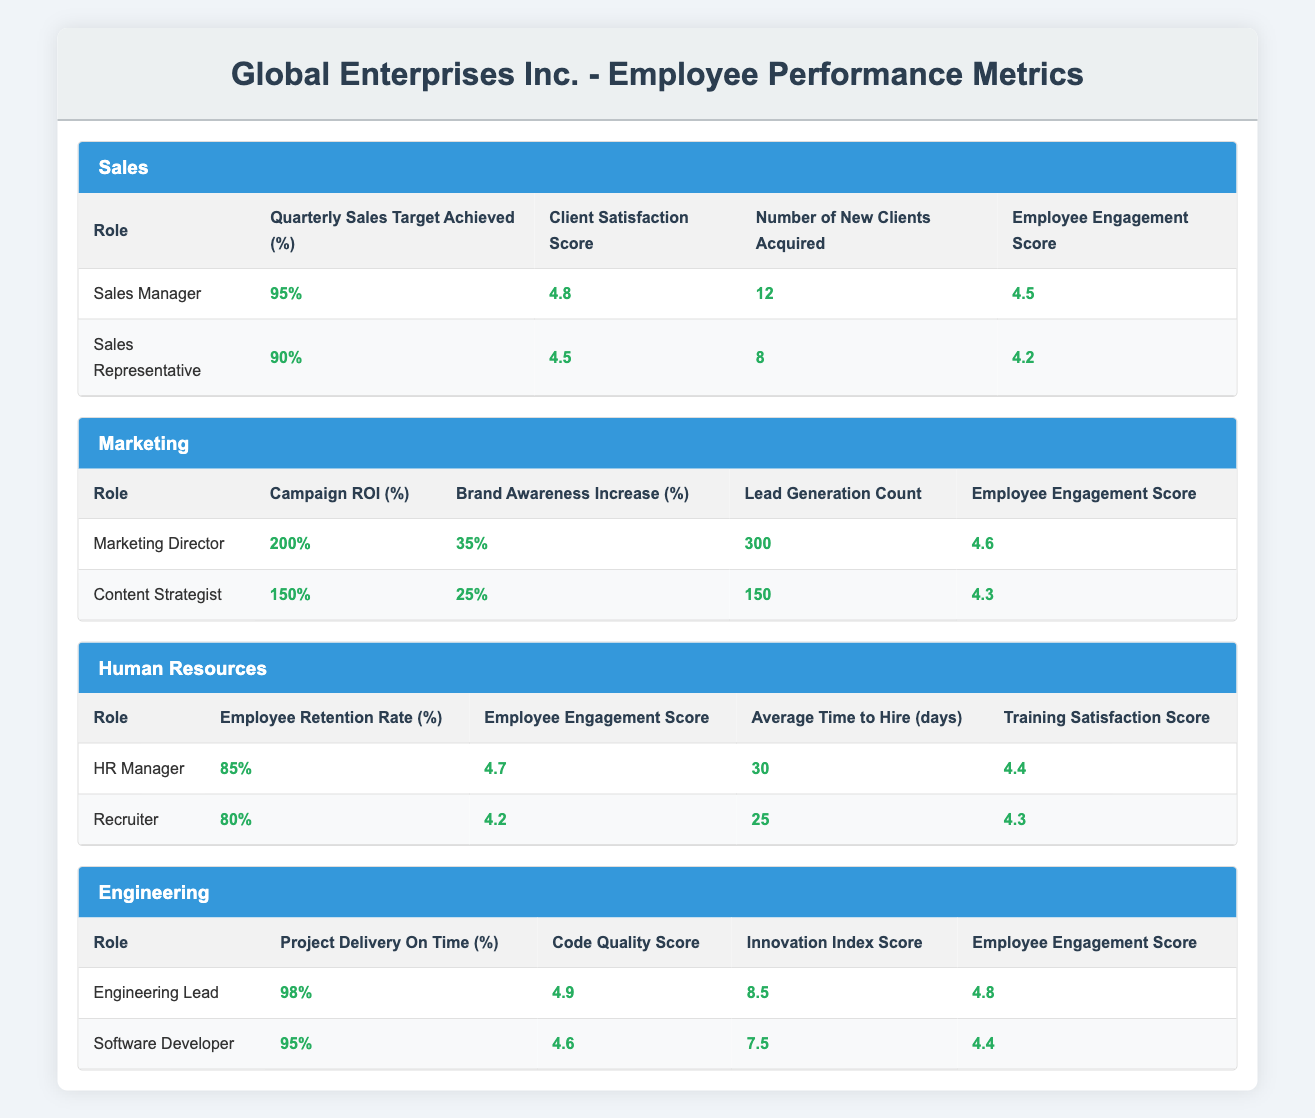What is the highest Employee Engagement Score among the roles? By inspecting the Employee Engagement Scores across all roles, the Sales Manager has a score of 4.5, the Marketing Director has 4.6, the HR Manager has 4.7, the Engineering Lead has 4.8, and the Software Developer has 4.4. The highest score is thus 4.8 from the Engineering Lead.
Answer: 4.8 What is the percentage of Quarterly Sales Target Achieved by the Sales Representative? Looking directly at the table under the Sales department, the Sales Representative has a Quarterly Sales Target Achieved of 90%.
Answer: 90% Did the Marketing Director achieve a Campaign ROI of more than 150%? The Campaign ROI for the Marketing Director is reported as 200%, which is indeed more than 150%. Therefore, the answer is yes.
Answer: Yes What is the average number of new clients acquired by the Sales roles? The Sales Manager acquired 12 new clients, while the Sales Representative acquired 8 new clients. To find the average, sum the two numbers (12 + 8 = 20) and then divide by 2, resulting in an average of 10 new clients acquired.
Answer: 10 Is the average time to hire shorter for the Recruiter than for the HR Manager? The HR Manager has an Average Time to Hire of 30 days, while the Recruiter has 25 days. Since 25 is less than 30, the answer is yes.
Answer: Yes What is the difference in Project Delivery On Time percentages between the Engineering Lead and the Software Developer? The Engineering Lead's Project Delivery On Time percentage is 98%, and the Software Developer's is 95%. The difference is calculated as 98 - 95 = 3%.
Answer: 3% Which role in Human Resources has a higher Employee Retention Rate? The HR Manager has an Employee Retention Rate of 85%, while the Recruiter has a rate of 80%. Therefore, the HR Manager has a higher retention rate.
Answer: HR Manager What is the total Campaign ROI achieved by both Marketing roles? The Marketing Director achieved a Campaign ROI of 200%, and the Content Strategist achieved 150%. Adding these two together gives 200 + 150 = 350%.
Answer: 350% Which department has the highest average Employee Engagement Score across its roles? Calculating the averages: Sales (4.5 + 4.2)/2 = 4.35, Marketing (4.6 + 4.3)/2 = 4.45, Human Resources (4.7 + 4.2)/2 = 4.45, and Engineering (4.8 + 4.4)/2 = 4.6. Thus, Engineering has the highest average of 4.6.
Answer: Engineering 